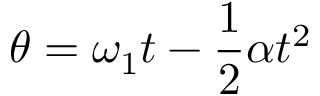<formula> <loc_0><loc_0><loc_500><loc_500>\theta = \omega _ { 1 } t - { \frac { 1 } { 2 } } \alpha t ^ { 2 }</formula> 